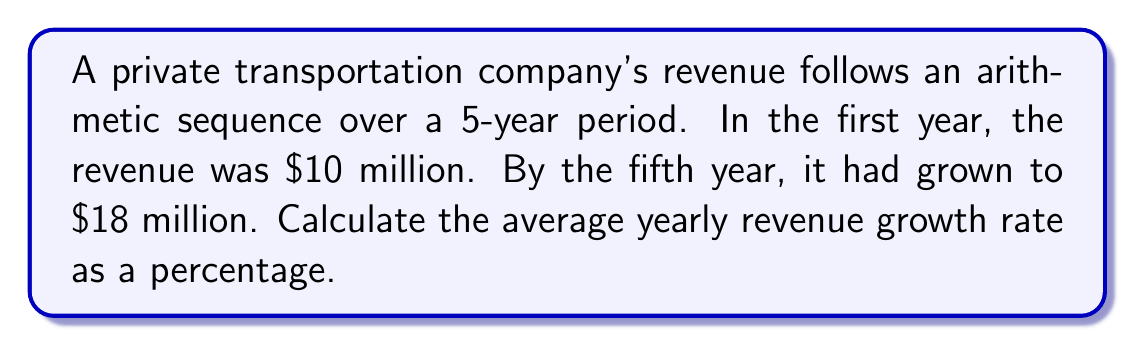Could you help me with this problem? Let's approach this step-by-step:

1) First, we need to find the common difference of the arithmetic sequence.
   Let $a_1 = 10$ million (first term) and $a_5 = 18$ million (fifth term).
   
   For an arithmetic sequence: $a_n = a_1 + (n-1)d$
   where $d$ is the common difference.

2) Substituting our values:
   $18 = 10 + (5-1)d$
   $18 = 10 + 4d$
   $8 = 4d$
   $d = 2$

3) So, the revenue increases by $2 million each year.

4) To calculate the growth rate, we need to find the average yearly increase as a percentage of the initial value:

   $$\text{Growth Rate} = \frac{\text{Yearly Increase}}{\text{Initial Value}} \times 100\%$$

5) Substituting our values:

   $$\text{Growth Rate} = \frac{2}{10} \times 100\% = 20\%$$

Therefore, the average yearly revenue growth rate is 20%.
Answer: 20% 